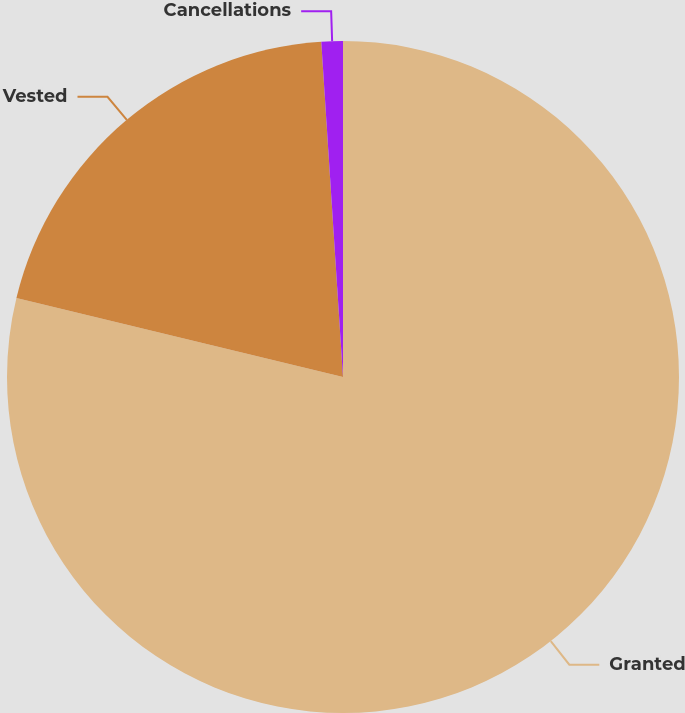<chart> <loc_0><loc_0><loc_500><loc_500><pie_chart><fcel>Granted<fcel>Vested<fcel>Cancellations<nl><fcel>78.78%<fcel>20.19%<fcel>1.03%<nl></chart> 